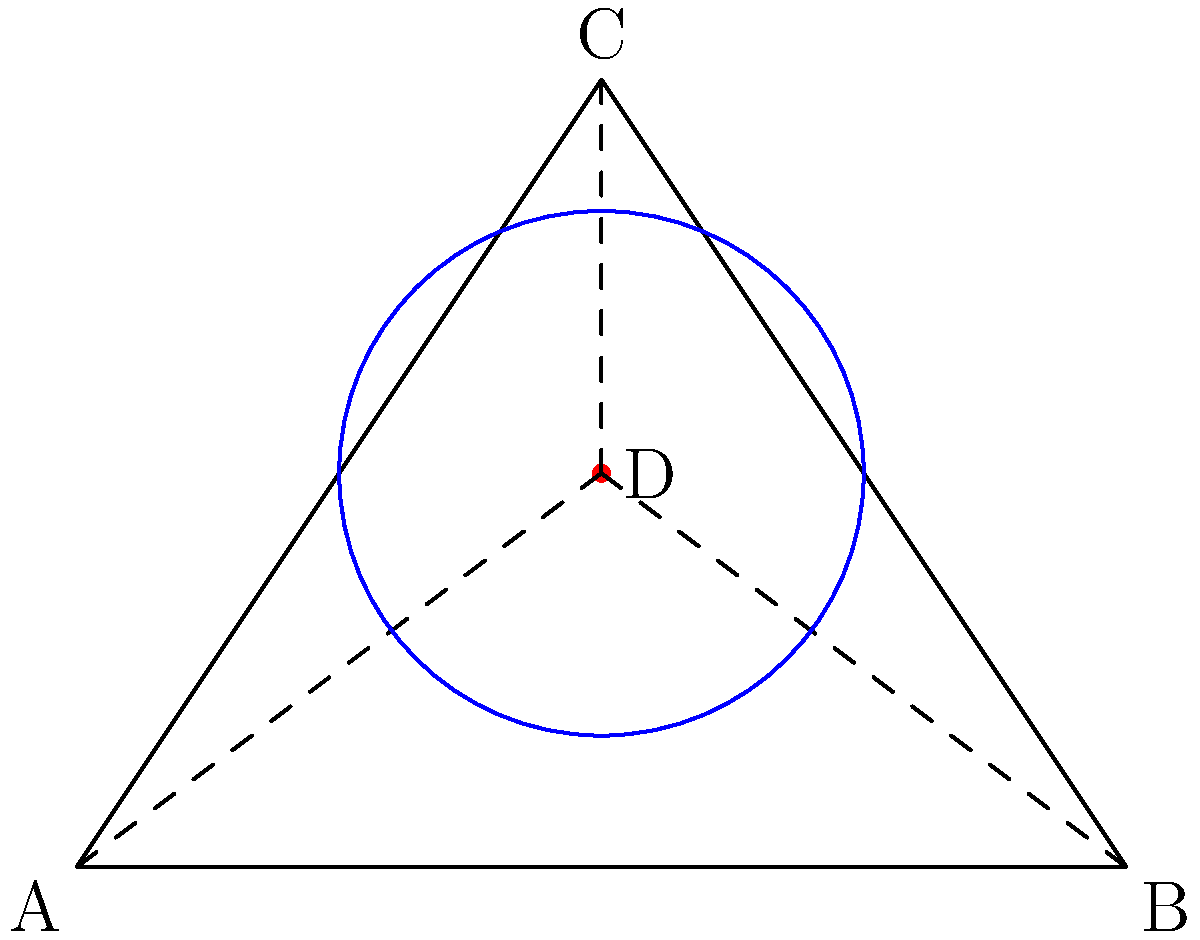In the triangle ABC, point D represents a nurse's workload perception. The Euclidean distances from D to each vertex (A, B, C) represent the perceived workload for different tasks. The non-Euclidean distances, measured along the surface of a sphere passing through A, B, C, and D, represent the actual workload. If the ratio of the sum of non-Euclidean distances to Euclidean distances is 1.2, what does this imply about the nurse's workload perception compared to reality? 1. The Euclidean distances are straight lines from D to A, B, and C, representing the nurse's perception of workload.

2. The non-Euclidean distances are measured along the surface of a sphere passing through A, B, C, and D, representing the actual workload.

3. The ratio of non-Euclidean to Euclidean distances is given as 1.2:
   $$ \frac{\text{Sum of non-Euclidean distances}}{\text{Sum of Euclidean distances}} = 1.2 $$

4. This ratio being greater than 1 implies that the non-Euclidean distances are longer than the Euclidean distances.

5. In the context of nursing workload:
   - Euclidean distances (shorter) represent perceived workload
   - Non-Euclidean distances (longer) represent actual workload

6. The ratio of 1.2 means the actual workload is 20% greater than the perceived workload.

7. This implies that the nurse is underestimating their actual workload by about 20%.
Answer: The nurse underestimates their actual workload by approximately 20%. 